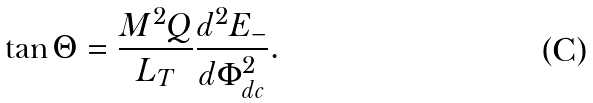<formula> <loc_0><loc_0><loc_500><loc_500>\tan \Theta = \frac { M ^ { 2 } Q } { L _ { T } } \frac { d ^ { 2 } E _ { - } } { d \Phi _ { d c } ^ { 2 } } .</formula> 